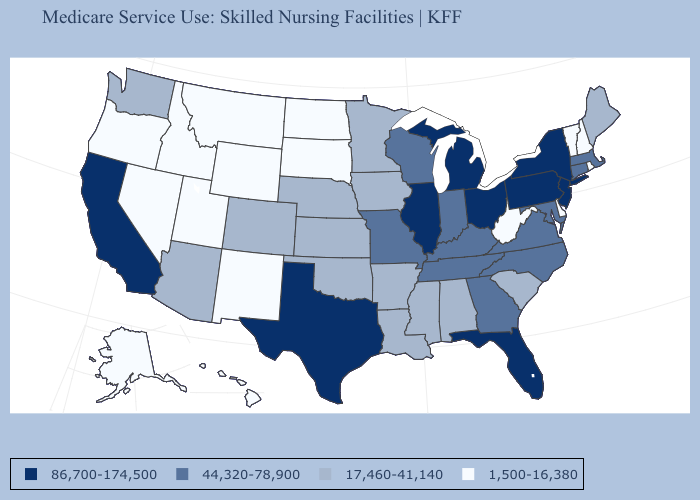Name the states that have a value in the range 17,460-41,140?
Give a very brief answer. Alabama, Arizona, Arkansas, Colorado, Iowa, Kansas, Louisiana, Maine, Minnesota, Mississippi, Nebraska, Oklahoma, South Carolina, Washington. Does Maine have the lowest value in the Northeast?
Give a very brief answer. No. What is the value of Illinois?
Short answer required. 86,700-174,500. What is the value of South Dakota?
Concise answer only. 1,500-16,380. Name the states that have a value in the range 86,700-174,500?
Write a very short answer. California, Florida, Illinois, Michigan, New Jersey, New York, Ohio, Pennsylvania, Texas. What is the value of Kansas?
Be succinct. 17,460-41,140. What is the value of Nevada?
Keep it brief. 1,500-16,380. Name the states that have a value in the range 44,320-78,900?
Answer briefly. Connecticut, Georgia, Indiana, Kentucky, Maryland, Massachusetts, Missouri, North Carolina, Tennessee, Virginia, Wisconsin. Which states hav the highest value in the Northeast?
Write a very short answer. New Jersey, New York, Pennsylvania. Name the states that have a value in the range 44,320-78,900?
Write a very short answer. Connecticut, Georgia, Indiana, Kentucky, Maryland, Massachusetts, Missouri, North Carolina, Tennessee, Virginia, Wisconsin. What is the highest value in the South ?
Be succinct. 86,700-174,500. Does Wisconsin have the highest value in the MidWest?
Short answer required. No. Does Arizona have the same value as Arkansas?
Short answer required. Yes. Does the map have missing data?
Quick response, please. No. Which states have the lowest value in the South?
Answer briefly. Delaware, West Virginia. 